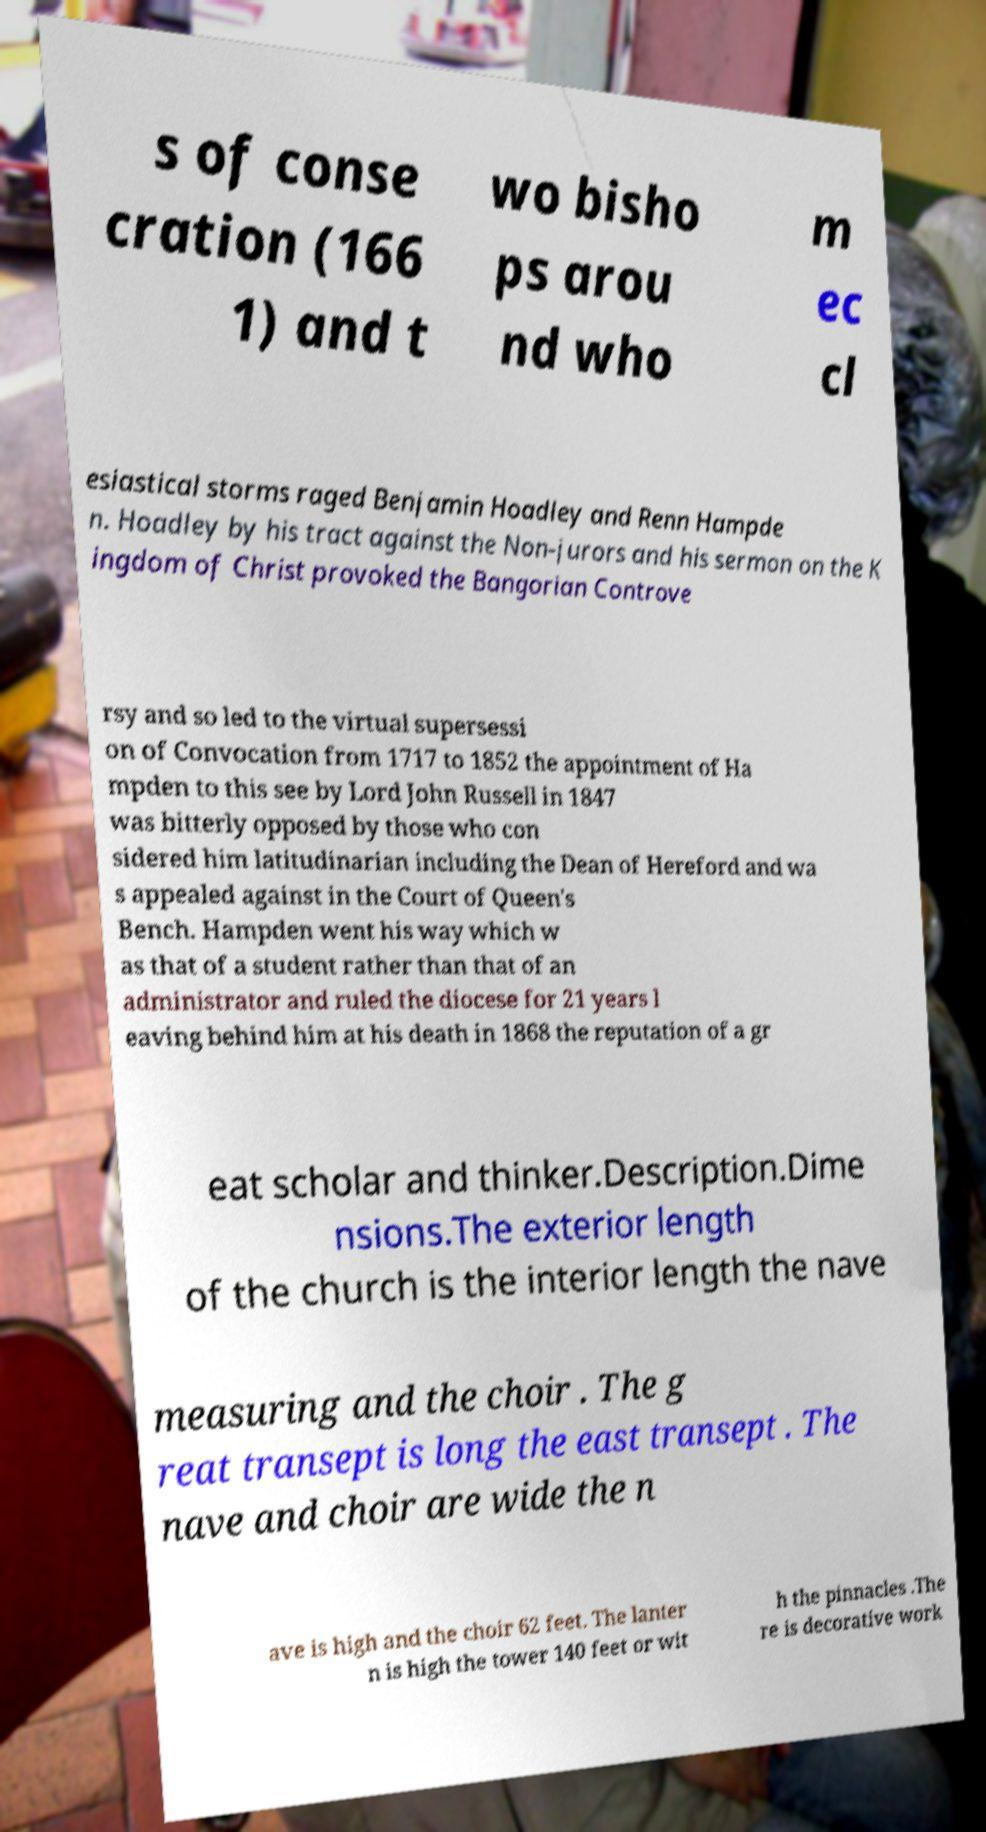Could you assist in decoding the text presented in this image and type it out clearly? s of conse cration (166 1) and t wo bisho ps arou nd who m ec cl esiastical storms raged Benjamin Hoadley and Renn Hampde n. Hoadley by his tract against the Non-jurors and his sermon on the K ingdom of Christ provoked the Bangorian Controve rsy and so led to the virtual supersessi on of Convocation from 1717 to 1852 the appointment of Ha mpden to this see by Lord John Russell in 1847 was bitterly opposed by those who con sidered him latitudinarian including the Dean of Hereford and wa s appealed against in the Court of Queen's Bench. Hampden went his way which w as that of a student rather than that of an administrator and ruled the diocese for 21 years l eaving behind him at his death in 1868 the reputation of a gr eat scholar and thinker.Description.Dime nsions.The exterior length of the church is the interior length the nave measuring and the choir . The g reat transept is long the east transept . The nave and choir are wide the n ave is high and the choir 62 feet. The lanter n is high the tower 140 feet or wit h the pinnacles .The re is decorative work 